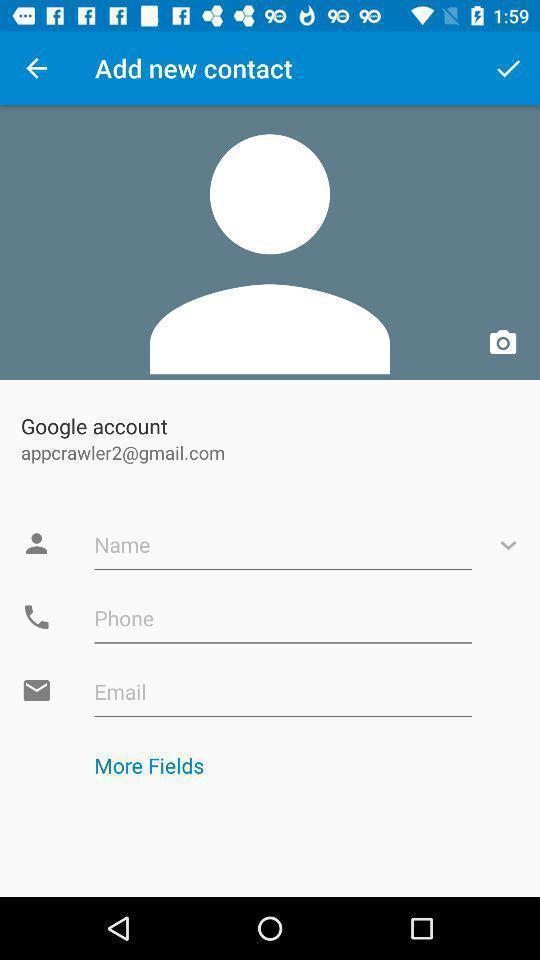What can you discern from this picture? Page requesting to edit the details of a new contact. 